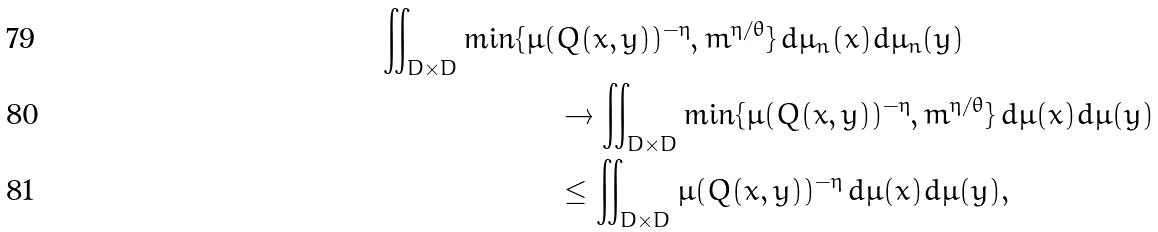Convert formula to latex. <formula><loc_0><loc_0><loc_500><loc_500>\iint _ { D \times D } \min \{ \mu ( & Q ( x , y ) ) ^ { - \eta } , m ^ { \eta / \theta } \} \, d \mu _ { n } ( x ) d \mu _ { n } ( y ) \\ & \to \iint _ { D \times D } \min \{ \mu ( Q ( x , y ) ) ^ { - \eta } , m ^ { \eta / \theta } \} \, d \mu ( x ) d \mu ( y ) \\ & \leq \iint _ { D \times D } \mu ( Q ( x , y ) ) ^ { - \eta } \, d \mu ( x ) d \mu ( y ) ,</formula> 